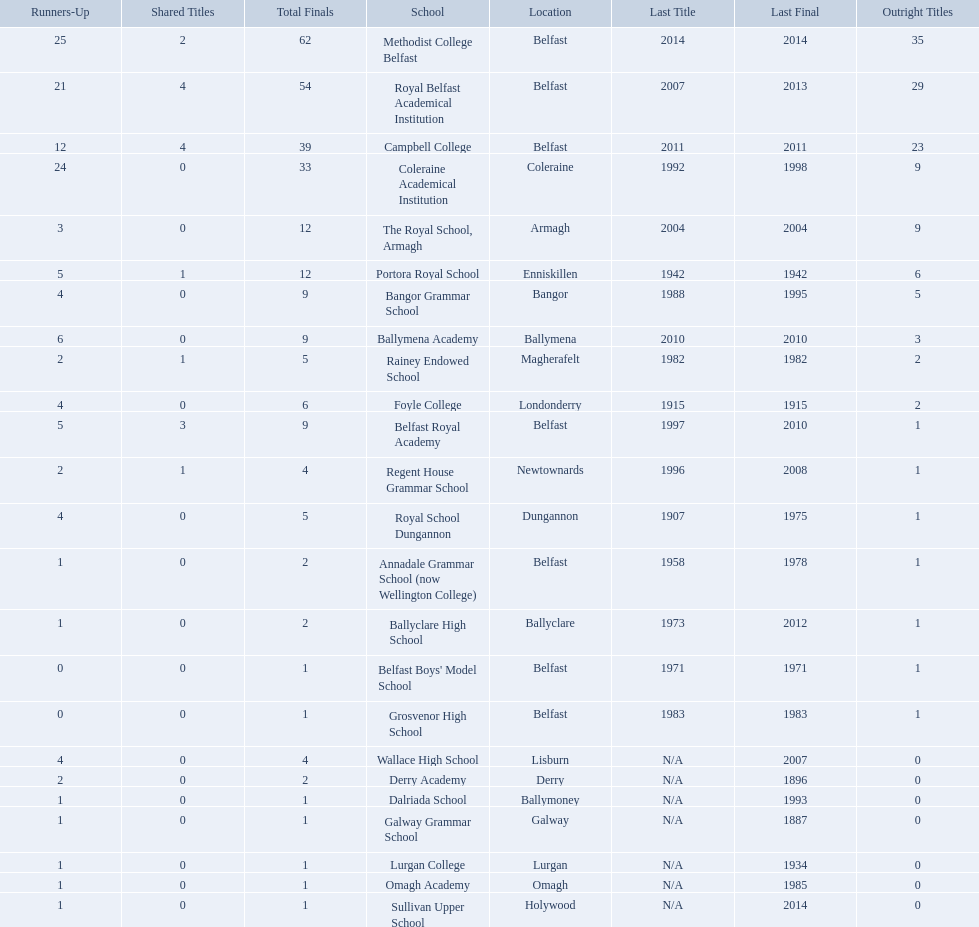How many schools are there? Methodist College Belfast, Royal Belfast Academical Institution, Campbell College, Coleraine Academical Institution, The Royal School, Armagh, Portora Royal School, Bangor Grammar School, Ballymena Academy, Rainey Endowed School, Foyle College, Belfast Royal Academy, Regent House Grammar School, Royal School Dungannon, Annadale Grammar School (now Wellington College), Ballyclare High School, Belfast Boys' Model School, Grosvenor High School, Wallace High School, Derry Academy, Dalriada School, Galway Grammar School, Lurgan College, Omagh Academy, Sullivan Upper School. How many outright titles does the coleraine academical institution have? 9. What other school has the same number of outright titles? The Royal School, Armagh. 